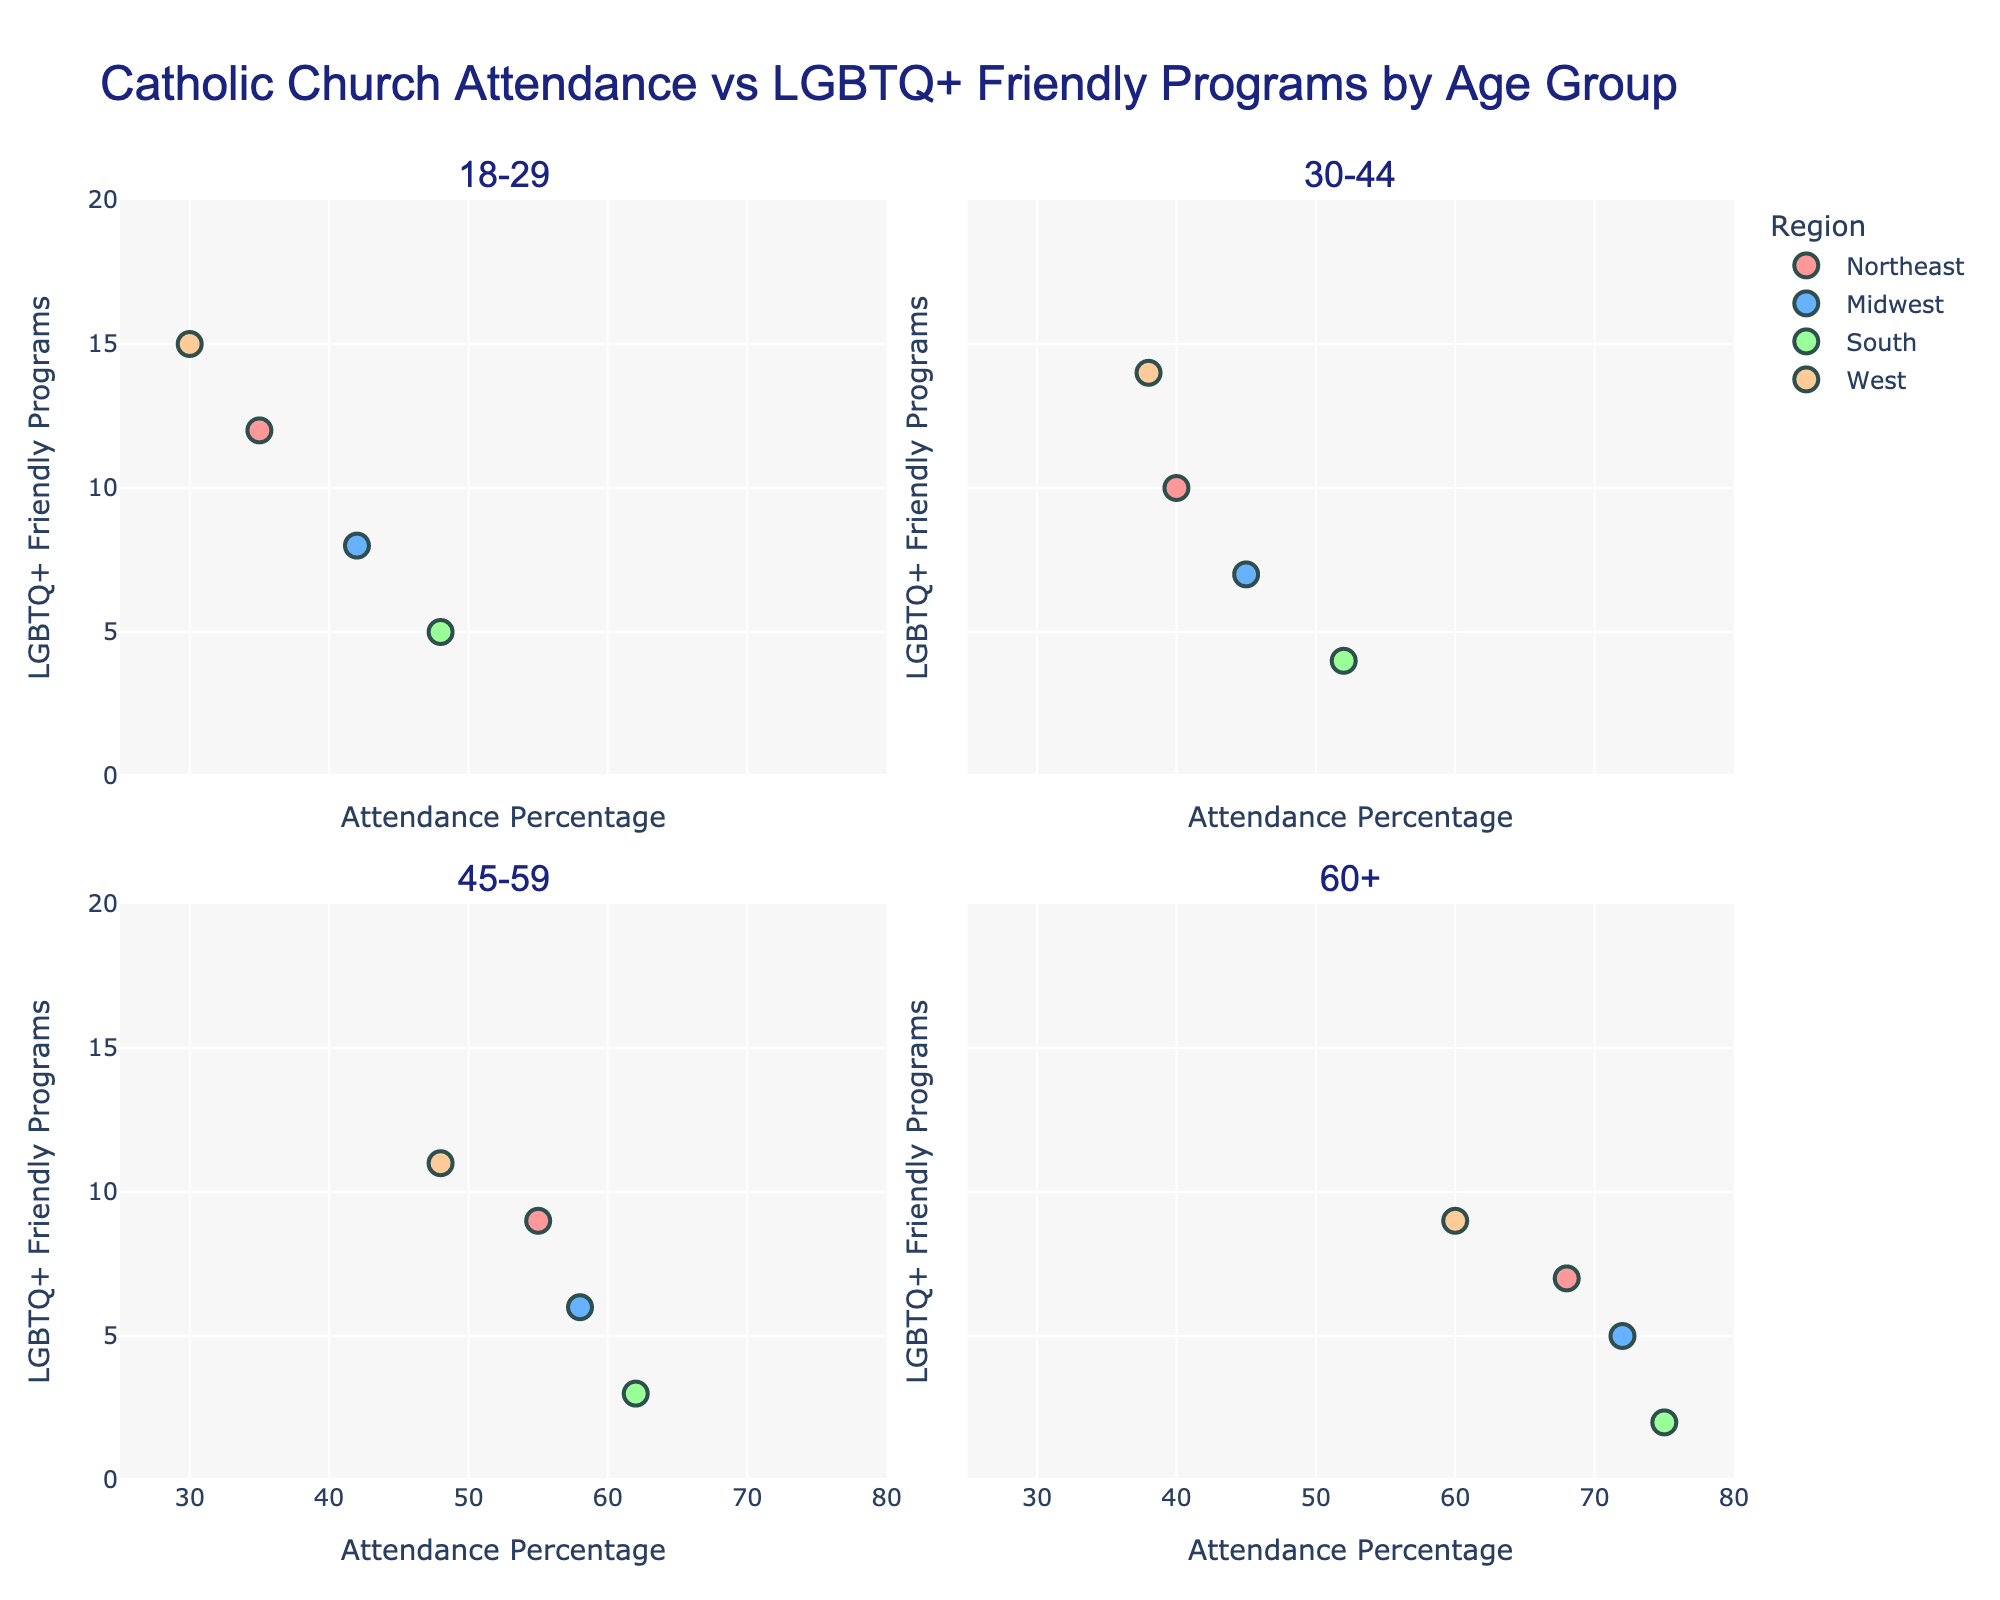What's the title of the figure? The title of the figure is always found at the top, providing an overview or context of the data being presented. In this figure, it's clearly displayed at the top.
Answer: Catholic Church Attendance vs LGBTQ+ Friendly Programs by Age Group Which region has the highest attendance percentage among 60+ age group? Look at the subplot for the 60+ age group and compare the X-axis values for all the regions. The highest attendance percentage point is visually the farthest to the right.
Answer: South How does the number of LGBTQ+ friendly programs change with age in the South region? Examine the South region points across all age groups and compare their Y-axis values. The number of programs decreases as age increases from 18-29 to 60+.
Answer: Decreases Which age group has the most spread in attendance percentages across different regions? Compare the X-axis spread of data points in each subplot. The subplot with the widest X-axis spread indicates the most variation in attendance percentages.
Answer: 18-29 In the 30-44 age group, which region has the fewest LGBTQ+ friendly programs? Look at the Y-axis values in the 30-44 subplot and find the point with the lowest Y value. The region corresponding to this low point represents the fewest programs.
Answer: South Among the Northeast regions, which age group attends church the most frequently? Compare the X-axis values of the Northeast data points across all age group subplots. Identify the age group with the highest percentage.
Answer: 60+ Is there any region where the attendance percentage and number of LGBTQ+ friendly programs vary inversely? Look for any region where, as attendance percentage increases (X-axis), the number of LGBTQ+ friendly programs (Y-axis) decreases. This inverse relationship can be seen in the South region subplots.
Answer: South What is the attendance percentage range for the Midwest region across all age groups? Identify the lowest and highest attendance percentages (X-axis values) for the Midwest region in all subplots. The lowest is 42% (18-29), and the highest is 72% (60+).
Answer: 42% to 72% Which age group in the West region has the highest number of LGBTQ+ friendly programs? Compare the Y-axis values of data points for the West region across all age group subplots. The highest Y value indicates the most programs.
Answer: 18-29 How does church attendance in the Midwest region for 45-59 age group compare to the West region for the same age group? Look at the 45-59 subplot and compare the X-axis values of the Midwest and West regions. The Midwest region point is farther right, indicating higher attendance percentage.
Answer: Higher in the Midwest 